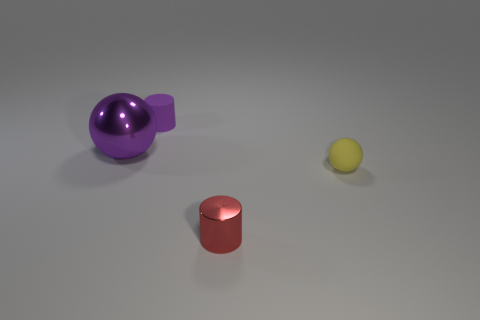Are there any other things that are the same size as the purple sphere?
Give a very brief answer. No. What number of balls are either yellow objects or tiny red things?
Provide a succinct answer. 1. There is another object that is the same shape as the tiny yellow thing; what size is it?
Make the answer very short. Large. How many tiny matte things are there?
Your answer should be very brief. 2. There is a small red thing; is it the same shape as the metallic object that is behind the red shiny cylinder?
Your answer should be very brief. No. There is a shiny object to the left of the red shiny cylinder; how big is it?
Give a very brief answer. Large. What is the yellow object made of?
Provide a succinct answer. Rubber. There is a small matte object to the left of the small yellow rubber sphere; is it the same shape as the tiny red metal object?
Offer a very short reply. Yes. There is a shiny sphere that is the same color as the small rubber cylinder; what size is it?
Your answer should be very brief. Large. Are there any matte things that have the same size as the matte sphere?
Ensure brevity in your answer.  Yes. 